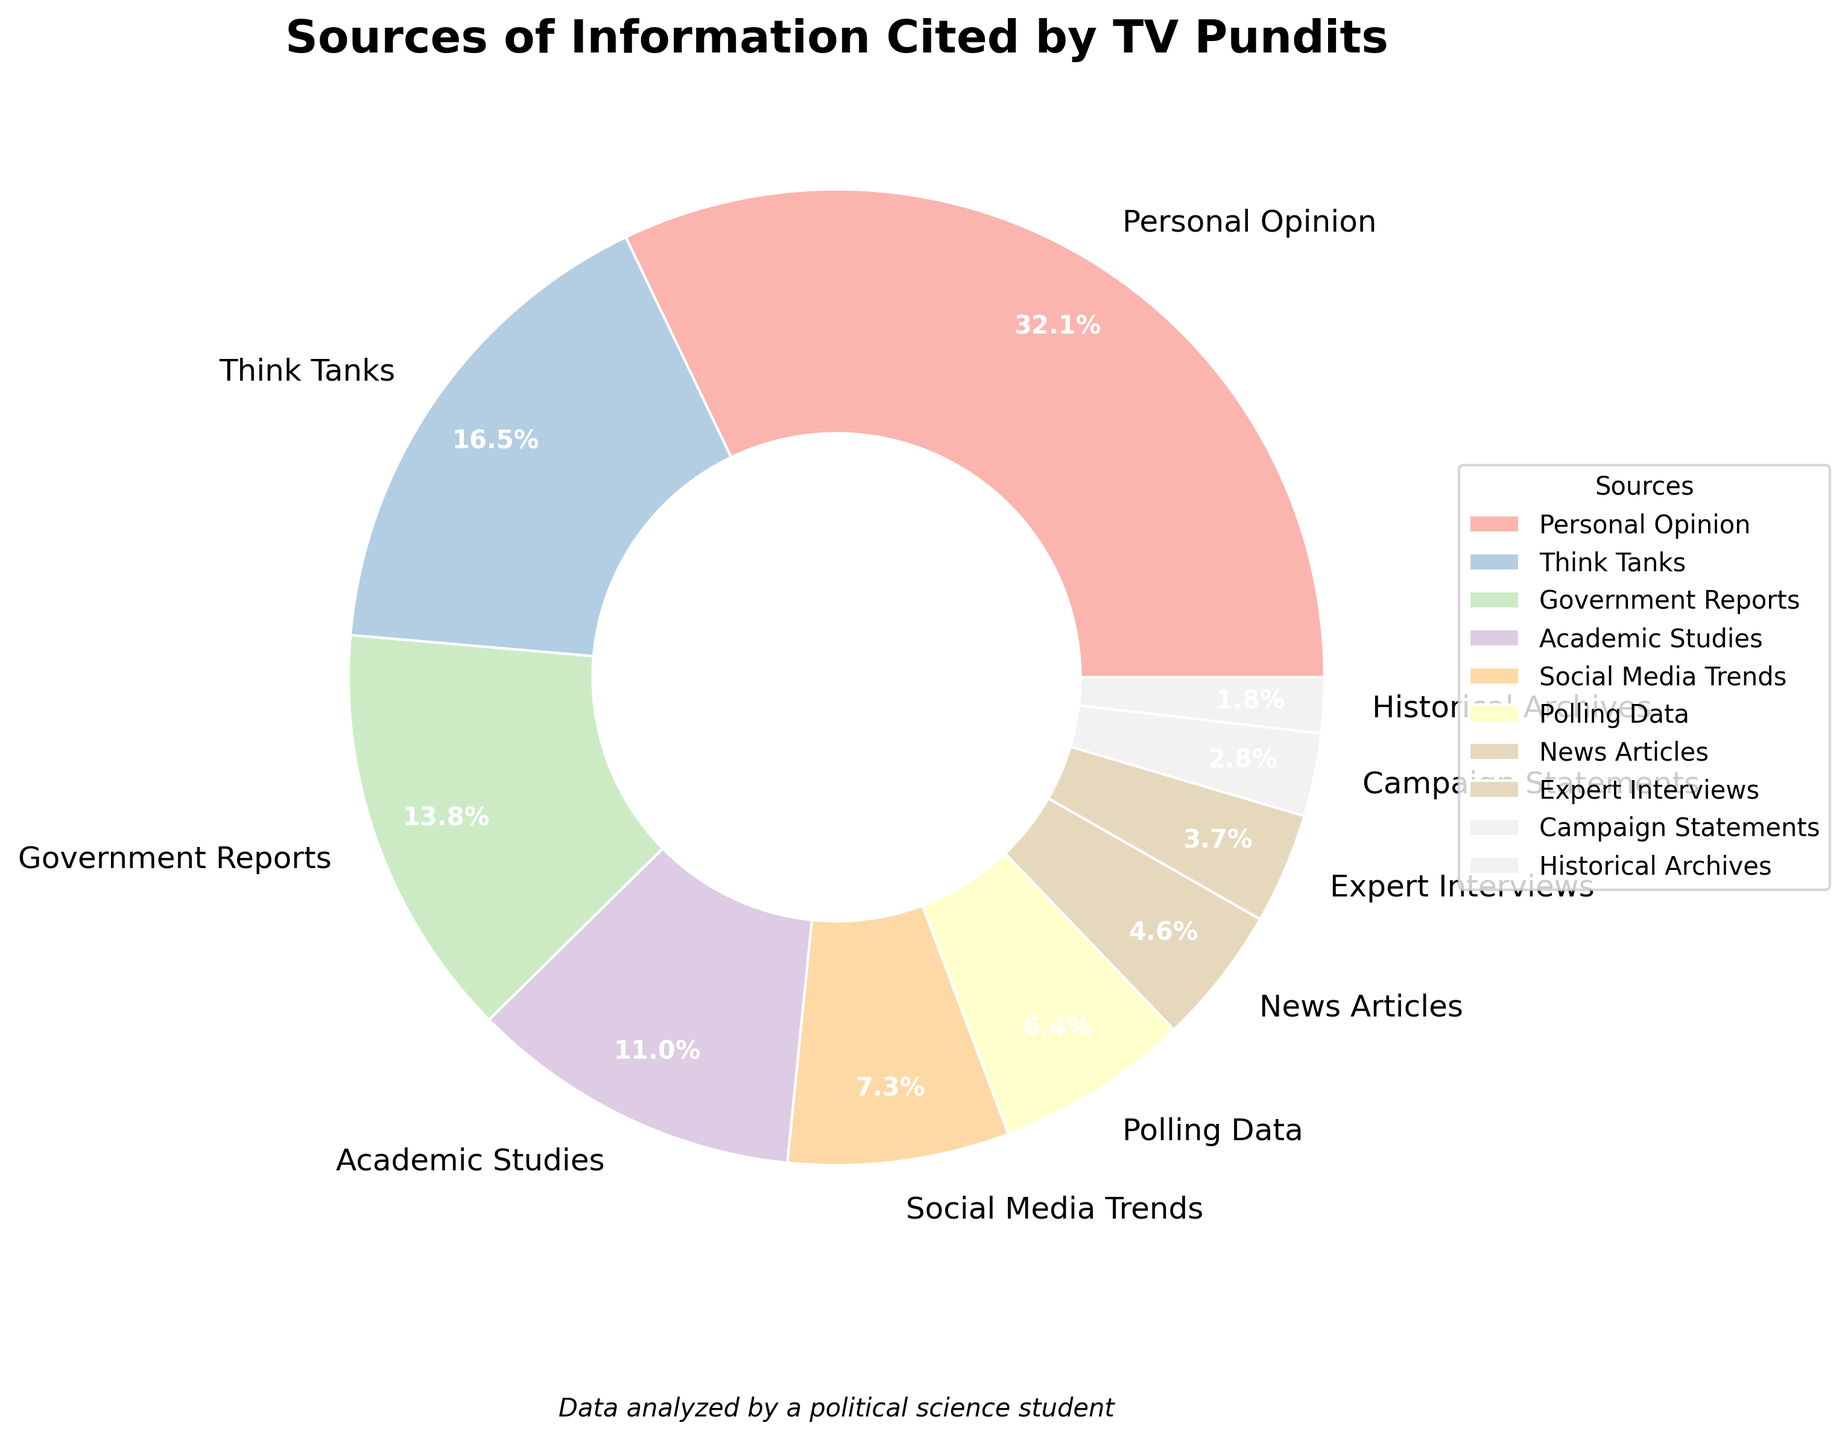what is the most cited source of information by TV pundits? By observing the pie chart, the largest segment represents the most cited source. The segment labeled "Personal Opinion" is the largest one at 35%.
Answer: Personal Opinion What percentage of sources come from either Academic Studies or Government Reports? By looking at the pie chart, find the segments labeled "Academic Studies" (12%) and "Government Reports" (15%). Add these percentages together: 12% + 15% = 27%.
Answer: 27% Among Think Tanks and Social Media Trends, which source is cited more and by how much? Refer to the portions labeled "Think Tanks" (18%) and "Social Media Trends" (8%). Subtract the smaller percentage from the larger one: 18% - 8% = 10%.
Answer: Think Tanks by 10% What is the total percentage of all sources except Personal Opinion? Identify all the other segments and add their percentages: Think Tanks (18%) + Government Reports (15%) + Academic Studies (12%) + Social Media Trends (8%) + Polling Data (7%) + News Articles (5%) + Expert Interviews (4%) + Campaign Statements (3%) + Historical Archives (2%) = 74%.
Answer: 74% Are expert interviews cited less frequently than polling data, and if so, by what percentage? Compare the segments for "Expert Interviews" (4%) and "Polling Data" (7%). Subtract the percentage of expert interviews from polling data: 7% - 4% = 3%.
Answer: Yes, by 3% 